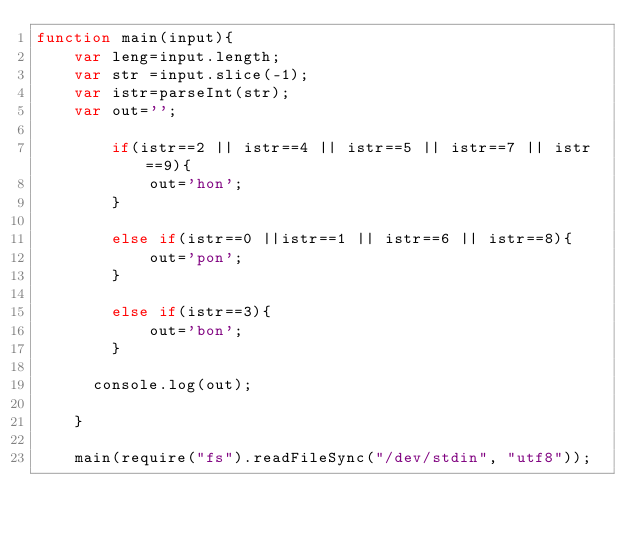<code> <loc_0><loc_0><loc_500><loc_500><_JavaScript_>function main(input){
    var leng=input.length;
    var str =input.slice(-1);
    var istr=parseInt(str);
    var out='';
  
  	    if(istr==2 || istr==4 || istr==5 || istr==7 || istr==9){
            out='hon';
        }
    
        else if(istr==0 ||istr==1 || istr==6 || istr==8){
            out='pon';
        }

        else if(istr==3){
            out='bon';
        }
      
      console.log(out);
     
    }
     
    main(require("fs").readFileSync("/dev/stdin", "utf8"));</code> 